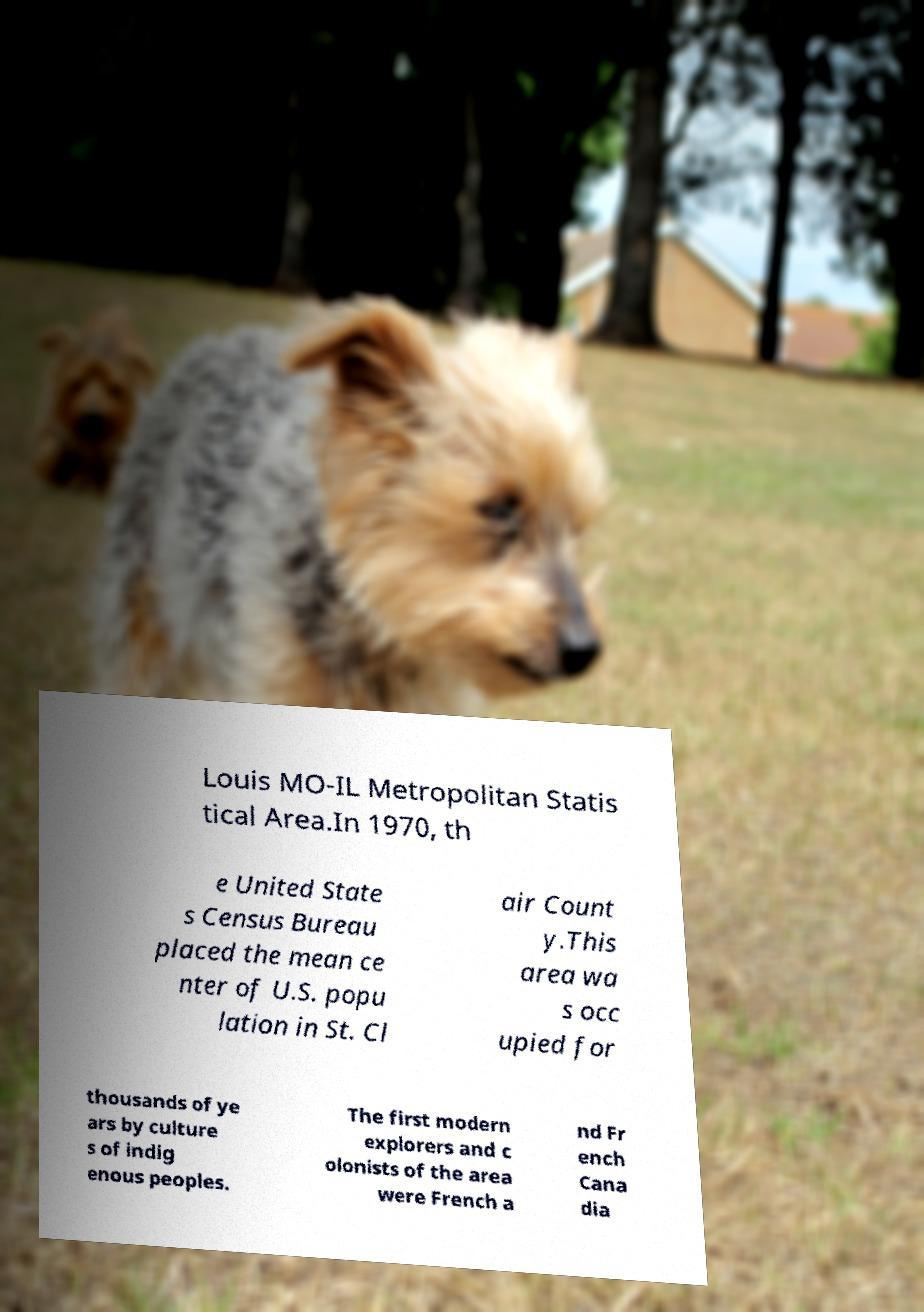I need the written content from this picture converted into text. Can you do that? Louis MO-IL Metropolitan Statis tical Area.In 1970, th e United State s Census Bureau placed the mean ce nter of U.S. popu lation in St. Cl air Count y.This area wa s occ upied for thousands of ye ars by culture s of indig enous peoples. The first modern explorers and c olonists of the area were French a nd Fr ench Cana dia 